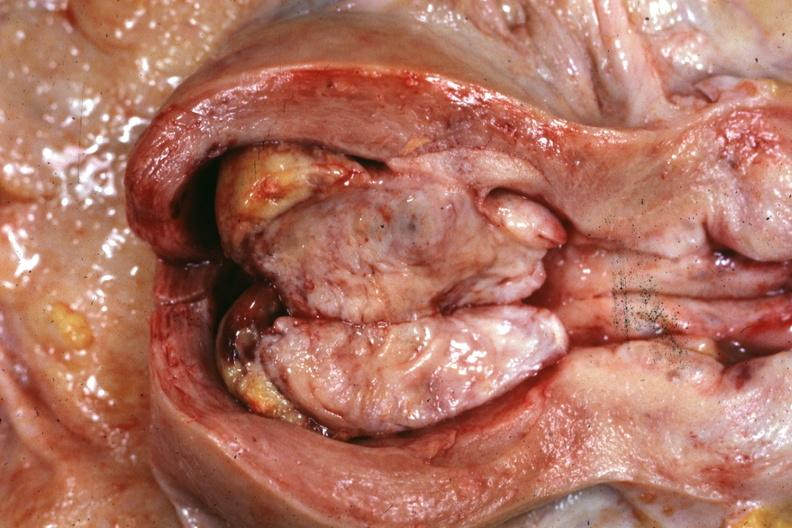does hand show opened uterus with polypoid mass?
Answer the question using a single word or phrase. No 